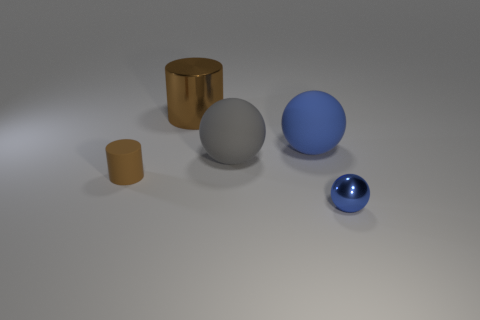Are there more large gray rubber spheres that are on the right side of the large blue ball than big brown matte blocks?
Ensure brevity in your answer.  No. What color is the metal thing behind the blue object that is in front of the blue thing behind the small shiny ball?
Ensure brevity in your answer.  Brown. Do the small blue ball and the big brown object have the same material?
Keep it short and to the point. Yes. Are there any cylinders that have the same size as the gray rubber sphere?
Give a very brief answer. Yes. There is a blue object that is the same size as the gray matte ball; what is it made of?
Ensure brevity in your answer.  Rubber. Are there any other blue matte things of the same shape as the blue rubber object?
Give a very brief answer. No. What is the material of the big thing that is the same color as the metallic sphere?
Your response must be concise. Rubber. There is a thing that is behind the big blue ball; what shape is it?
Keep it short and to the point. Cylinder. What number of small brown rubber cubes are there?
Ensure brevity in your answer.  0. There is a tiny object that is made of the same material as the big brown thing; what is its color?
Offer a very short reply. Blue. 